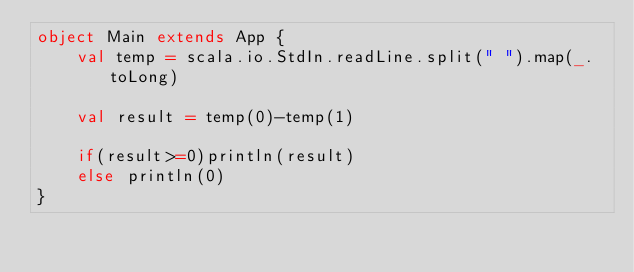<code> <loc_0><loc_0><loc_500><loc_500><_Scala_>object Main extends App {
	val temp = scala.io.StdIn.readLine.split(" ").map(_.toLong)

	val result = temp(0)-temp(1)

	if(result>=0)println(result)
	else println(0)
}</code> 